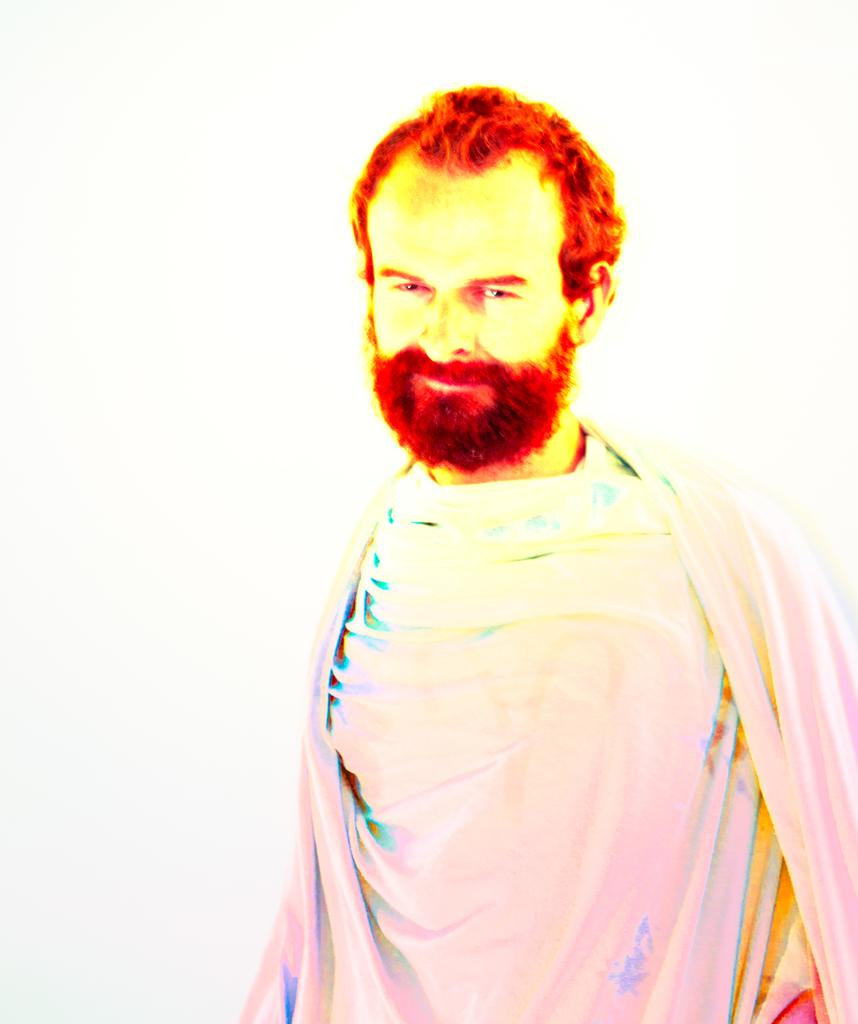Who is present in the image? There is a man in the image. What color is the background of the image? The background of the image is white. What type of test is the man taking in the image? There is no indication of a test in the image; it only shows a man with a white background. 